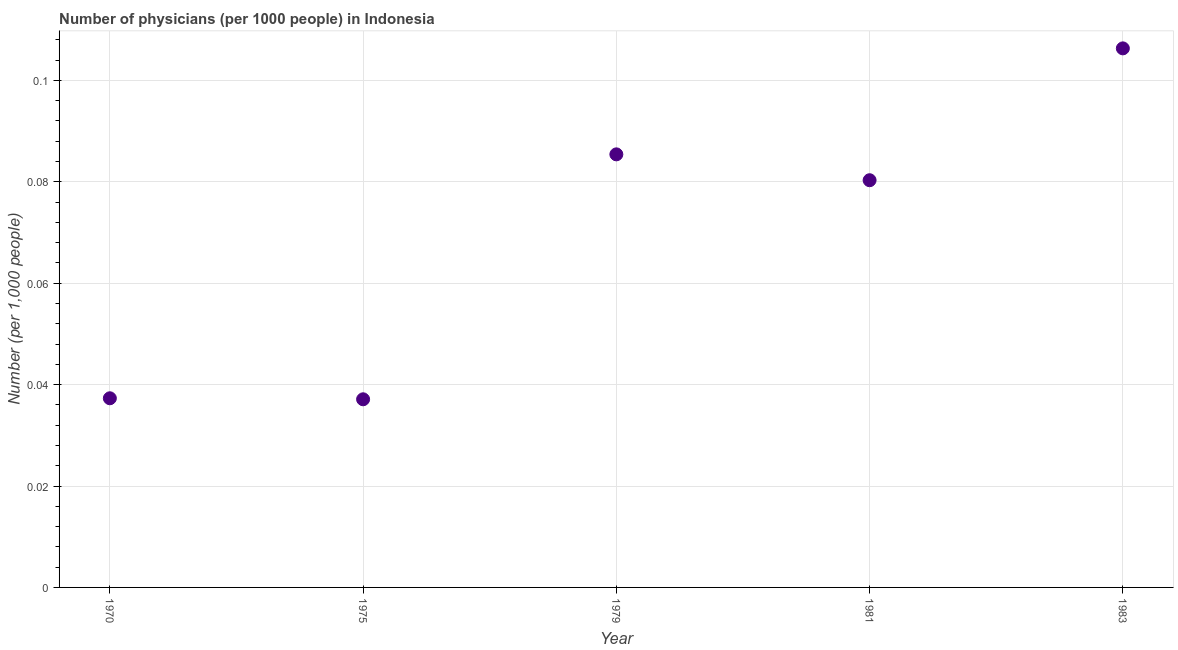What is the number of physicians in 1979?
Offer a terse response. 0.09. Across all years, what is the maximum number of physicians?
Your answer should be very brief. 0.11. Across all years, what is the minimum number of physicians?
Provide a succinct answer. 0.04. In which year was the number of physicians maximum?
Provide a succinct answer. 1983. In which year was the number of physicians minimum?
Ensure brevity in your answer.  1975. What is the sum of the number of physicians?
Your answer should be compact. 0.35. What is the difference between the number of physicians in 1981 and 1983?
Provide a succinct answer. -0.03. What is the average number of physicians per year?
Your answer should be very brief. 0.07. What is the median number of physicians?
Your response must be concise. 0.08. Do a majority of the years between 1975 and 1983 (inclusive) have number of physicians greater than 0.048 ?
Your response must be concise. Yes. What is the ratio of the number of physicians in 1970 to that in 1983?
Give a very brief answer. 0.35. Is the number of physicians in 1979 less than that in 1981?
Keep it short and to the point. No. Is the difference between the number of physicians in 1975 and 1979 greater than the difference between any two years?
Give a very brief answer. No. What is the difference between the highest and the second highest number of physicians?
Your answer should be very brief. 0.02. Is the sum of the number of physicians in 1975 and 1979 greater than the maximum number of physicians across all years?
Your answer should be compact. Yes. What is the difference between the highest and the lowest number of physicians?
Your answer should be very brief. 0.07. In how many years, is the number of physicians greater than the average number of physicians taken over all years?
Make the answer very short. 3. Are the values on the major ticks of Y-axis written in scientific E-notation?
Your answer should be very brief. No. Does the graph contain any zero values?
Ensure brevity in your answer.  No. What is the title of the graph?
Your response must be concise. Number of physicians (per 1000 people) in Indonesia. What is the label or title of the Y-axis?
Your answer should be compact. Number (per 1,0 people). What is the Number (per 1,000 people) in 1970?
Make the answer very short. 0.04. What is the Number (per 1,000 people) in 1975?
Your answer should be very brief. 0.04. What is the Number (per 1,000 people) in 1979?
Your response must be concise. 0.09. What is the Number (per 1,000 people) in 1981?
Make the answer very short. 0.08. What is the Number (per 1,000 people) in 1983?
Give a very brief answer. 0.11. What is the difference between the Number (per 1,000 people) in 1970 and 1979?
Give a very brief answer. -0.05. What is the difference between the Number (per 1,000 people) in 1970 and 1981?
Your answer should be compact. -0.04. What is the difference between the Number (per 1,000 people) in 1970 and 1983?
Ensure brevity in your answer.  -0.07. What is the difference between the Number (per 1,000 people) in 1975 and 1979?
Give a very brief answer. -0.05. What is the difference between the Number (per 1,000 people) in 1975 and 1981?
Offer a terse response. -0.04. What is the difference between the Number (per 1,000 people) in 1975 and 1983?
Offer a very short reply. -0.07. What is the difference between the Number (per 1,000 people) in 1979 and 1981?
Provide a short and direct response. 0.01. What is the difference between the Number (per 1,000 people) in 1979 and 1983?
Make the answer very short. -0.02. What is the difference between the Number (per 1,000 people) in 1981 and 1983?
Offer a terse response. -0.03. What is the ratio of the Number (per 1,000 people) in 1970 to that in 1979?
Offer a very short reply. 0.44. What is the ratio of the Number (per 1,000 people) in 1970 to that in 1981?
Provide a short and direct response. 0.47. What is the ratio of the Number (per 1,000 people) in 1970 to that in 1983?
Your answer should be very brief. 0.35. What is the ratio of the Number (per 1,000 people) in 1975 to that in 1979?
Ensure brevity in your answer.  0.43. What is the ratio of the Number (per 1,000 people) in 1975 to that in 1981?
Offer a very short reply. 0.46. What is the ratio of the Number (per 1,000 people) in 1975 to that in 1983?
Keep it short and to the point. 0.35. What is the ratio of the Number (per 1,000 people) in 1979 to that in 1981?
Give a very brief answer. 1.06. What is the ratio of the Number (per 1,000 people) in 1979 to that in 1983?
Make the answer very short. 0.8. What is the ratio of the Number (per 1,000 people) in 1981 to that in 1983?
Your response must be concise. 0.76. 